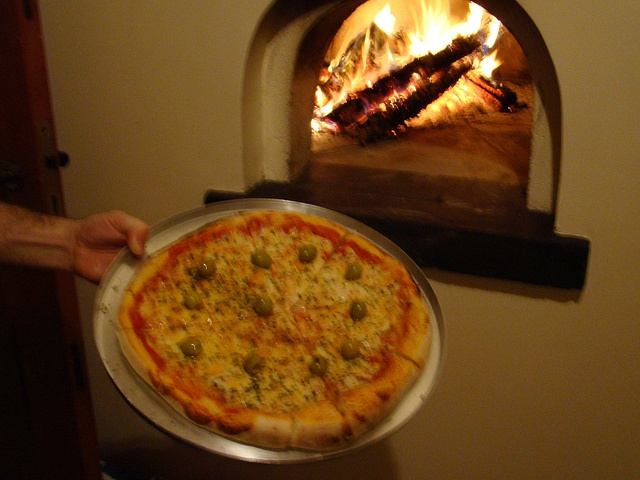Describe the objects in this image and their specific colors. I can see oven in black, maroon, and olive tones, pizza in black, olive, and maroon tones, pizza in black, olive, and maroon tones, and people in black, maroon, and brown tones in this image. 